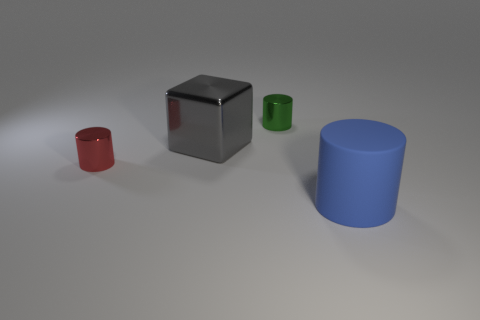What is the size of the thing that is both in front of the shiny cube and on the left side of the small green cylinder?
Offer a very short reply. Small. What is the shape of the big gray object?
Offer a very short reply. Cube. There is a large object behind the large blue rubber object; is there a tiny red metal thing that is behind it?
Make the answer very short. No. There is a large object left of the tiny green shiny cylinder; how many metal blocks are right of it?
Your response must be concise. 0. What material is the cylinder that is the same size as the gray thing?
Offer a very short reply. Rubber. There is a small metal thing behind the gray metallic object; is its shape the same as the large gray metal thing?
Keep it short and to the point. No. Is the number of big objects that are to the right of the blue cylinder greater than the number of blue cylinders that are left of the tiny green cylinder?
Your answer should be compact. No. How many large cubes are made of the same material as the small red thing?
Provide a short and direct response. 1. Do the gray metallic block and the blue matte thing have the same size?
Your answer should be compact. Yes. The rubber cylinder is what color?
Give a very brief answer. Blue. 